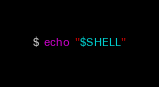Convert code to text. <code><loc_0><loc_0><loc_500><loc_500><_Bash_>$ echo "$SHELL"
</code> 